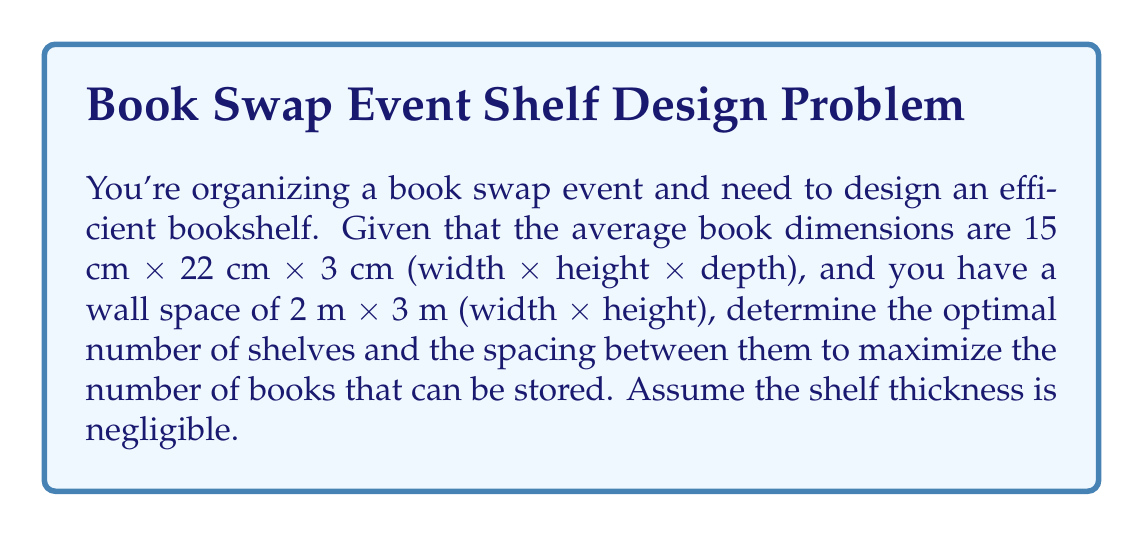Provide a solution to this math problem. 1. Calculate the number of books that can fit horizontally on one shelf:
   $$ \text{Books per row} = \left\lfloor\frac{200 \text{ cm}}{15 \text{ cm}}\right\rfloor = 13 \text{ books} $$

2. Calculate the total height available for books:
   $$ \text{Available height} = 300 \text{ cm} $$

3. Let $x$ be the number of shelves. The space between shelves should be slightly larger than the book height:
   $$ \text{Shelf spacing} = 22 \text{ cm} + \epsilon \approx 23 \text{ cm} $$

4. The number of shelves that can fit vertically:
   $$ x = \left\lfloor\frac{300 \text{ cm}}{23 \text{ cm}}\right\rfloor = 13 \text{ shelves} $$

5. Calculate the total number of books that can be stored:
   $$ \text{Total books} = 13 \text{ books/row} \times 13 \text{ shelves} = 169 \text{ books} $$

6. Verify that the depth of the shelf is sufficient:
   $$ \text{Shelf depth} \geq 3 \text{ cm (book depth)} $$

7. The optimal dimensions for the bookshelf:
   - Width: 2 m (wall width)
   - Height: 3 m (wall height)
   - Number of shelves: 13
   - Spacing between shelves: 23 cm
Answer: 13 shelves, 23 cm spacing 